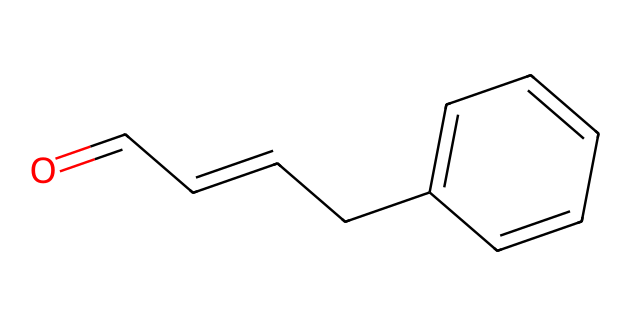What is the molecular formula of cinnamaldehyde? To find the molecular formula, count the different types of atoms in the chemical structure. The given SMILES shows one carbonyl group (O=), which contributes one oxygen atom, followed by a total of 9 carbon atoms in the carbon skeleton, and 10 hydrogen atoms. Therefore, the molecular formula is C9H8O.
Answer: C9H8O How many carbon atoms are present in cinnamaldehyde? By examining the SMILES representation, count the carbon atoms. The string has nine carbon atoms present in the structure, confirmed both by the carbonyl and the remaining carbon chain.
Answer: 9 What type of functional group is exhibited by cinnamaldehyde? The structure includes a carbonyl group (C=O) and is attached to a carbon chain, which is characteristic of aldehydes. This specific functional group gives it the properties of an aldehyde.
Answer: aldehyde What is the degree of unsaturation in cinnamaldehyde? The degree of unsaturation can be calculated by considering the rings and double bonds in the structure. Each ring or double bond counts as one degree of unsaturation. In cinnamaldehyde, there are two double bonds (one from the carbonyl group and one in the alkene) and no rings, leading to a degree of unsaturation of two.
Answer: 2 What is the significance of the carbonyl group in cinnamaldehyde? The carbonyl group (C=O) defines the compound as an aldehyde, influencing its reactivity and functional properties, such as its aroma, and it allows for nucleophilic attack which is fundamental in chemical reactions.
Answer: reactivity What is the main reason cinnamaldehyde has a pleasant scent? The structure of cinnamaldehyde includes aromatic rings, and it is the unique combination of the aldehyde group and the aromatic system that gives cinnamon its characteristic smell, which is appealing.
Answer: aromatic system 